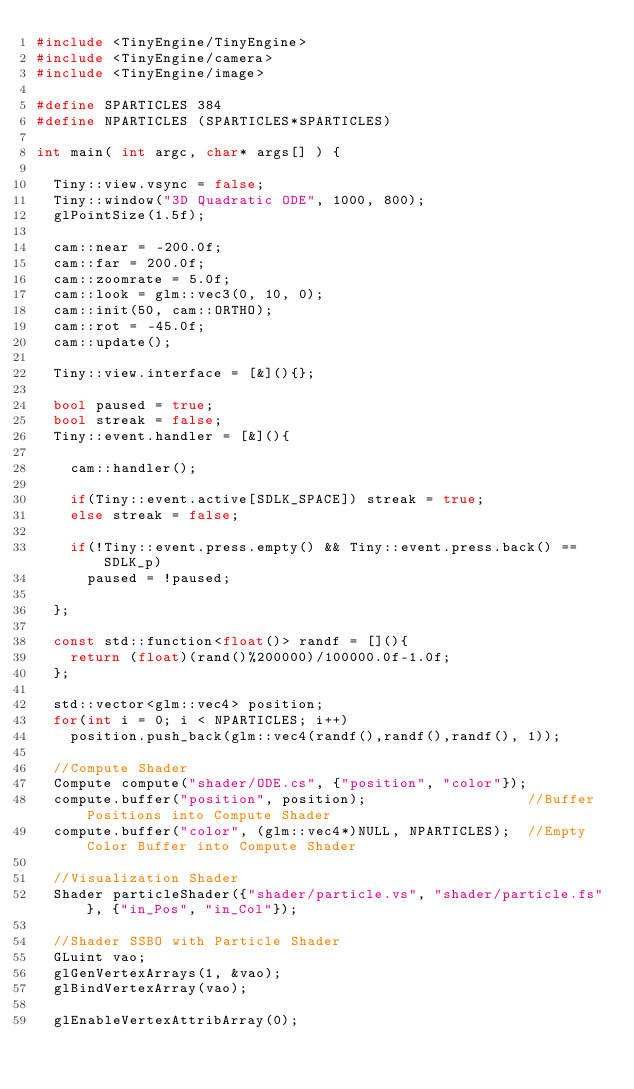Convert code to text. <code><loc_0><loc_0><loc_500><loc_500><_C++_>#include <TinyEngine/TinyEngine>
#include <TinyEngine/camera>
#include <TinyEngine/image>

#define SPARTICLES 384
#define NPARTICLES (SPARTICLES*SPARTICLES)

int main( int argc, char* args[] ) {

	Tiny::view.vsync = false;
	Tiny::window("3D Quadratic ODE", 1000, 800);
	glPointSize(1.5f);

  cam::near = -200.0f;
	cam::far = 200.0f;
	cam::zoomrate = 5.0f;
	cam::look = glm::vec3(0, 10, 0);
	cam::init(50, cam::ORTHO);
	cam::rot = -45.0f;
	cam::update();

	Tiny::view.interface = [&](){};

	bool paused = true;
	bool streak = false;
  Tiny::event.handler = [&](){

		cam::handler();

		if(Tiny::event.active[SDLK_SPACE]) streak = true;
		else streak = false;

		if(!Tiny::event.press.empty() && Tiny::event.press.back() == SDLK_p)
			paused = !paused;

	};

	const std::function<float()> randf = [](){
		return (float)(rand()%200000)/100000.0f-1.0f;
	};

	std::vector<glm::vec4> position;
	for(int i = 0; i < NPARTICLES; i++)
		position.push_back(glm::vec4(randf(),randf(),randf(), 1));

  //Compute Shader
	Compute compute("shader/ODE.cs", {"position", "color"});
	compute.buffer("position", position);										//Buffer Positions into Compute Shader
	compute.buffer("color", (glm::vec4*)NULL, NPARTICLES);	//Empty Color Buffer into Compute Shader

	//Visualization Shader
	Shader particleShader({"shader/particle.vs", "shader/particle.fs"}, {"in_Pos", "in_Col"});

	//Shader SSBO with Particle Shader
	GLuint vao;
	glGenVertexArrays(1, &vao);
	glBindVertexArray(vao);

	glEnableVertexAttribArray(0);</code> 